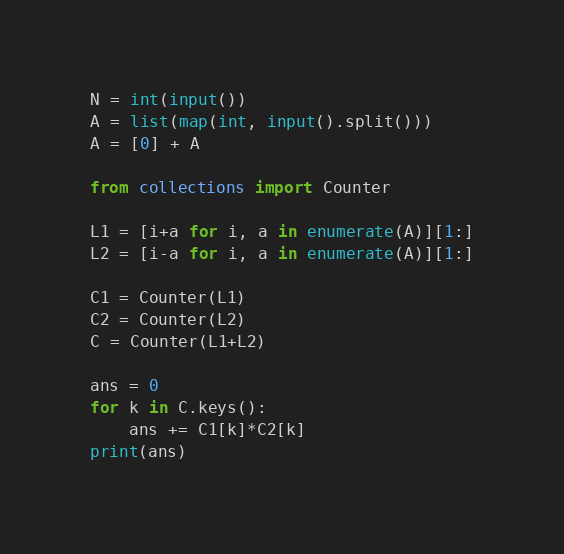<code> <loc_0><loc_0><loc_500><loc_500><_Python_>N = int(input())
A = list(map(int, input().split()))
A = [0] + A

from collections import Counter

L1 = [i+a for i, a in enumerate(A)][1:]
L2 = [i-a for i, a in enumerate(A)][1:]

C1 = Counter(L1)
C2 = Counter(L2)
C = Counter(L1+L2)

ans = 0
for k in C.keys():
    ans += C1[k]*C2[k]
print(ans)</code> 